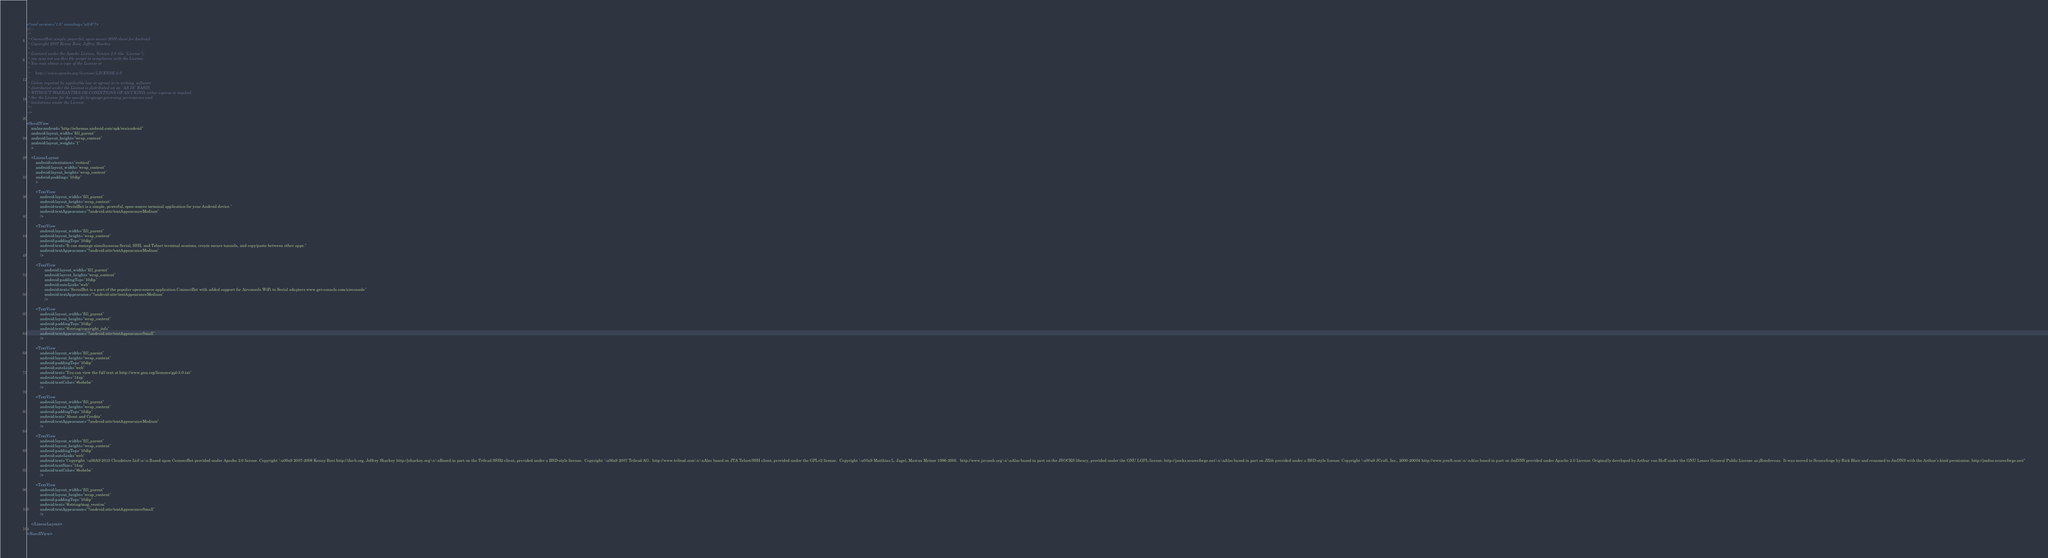<code> <loc_0><loc_0><loc_500><loc_500><_XML_><?xml version="1.0" encoding="utf-8"?>
<!--
/*
 * ConnectBot: simple, powerful, open-source SSH client for Android
 * Copyright 2007 Kenny Root, Jeffrey Sharkey
 *
 * Licensed under the Apache License, Version 2.0 (the "License");
 * you may not use this file except in compliance with the License.
 * You may obtain a copy of the License at
 *
 *     http://www.apache.org/licenses/LICENSE-2.0
 *
 * Unless required by applicable law or agreed to in writing, software
 * distributed under the License is distributed on an "AS IS" BASIS,
 * WITHOUT WARRANTIES OR CONDITIONS OF ANY KIND, either express or implied.
 * See the License for the specific language governing permissions and
 * limitations under the License.
 */
-->

<ScrollView
	xmlns:android="http://schemas.android.com/apk/res/android"
	android:layout_width="fill_parent"
	android:layout_height="wrap_content"
	android:layout_weight="1"
	>

	<LinearLayout
		android:orientation="vertical"
		android:layout_width="wrap_content"
		android:layout_height="wrap_content"
		android:padding="10dip"
		>

		<TextView
			android:layout_width="fill_parent"
			android:layout_height="wrap_content"
			android:text="SerialBot is a simple, powerful, open-source terminal application for your Android device."
			android:textAppearance="?android:attr/textAppearanceMedium"
			/>

		<TextView
			android:layout_width="fill_parent"
			android:layout_height="wrap_content"
			android:paddingTop="10dip"
			android:text="It can manage simultaneous Serial, SSH, and Telnet terminal sessions, create secure tunnels, and copy/paste between other apps."
			android:textAppearance="?android:attr/textAppearanceMedium"
			/>

        <TextView
                android:layout_width="fill_parent"
                android:layout_height="wrap_content"
                android:paddingTop="10dip"
                android:autoLink="web"
                android:text="SerialBot is a port of the popular open-source application ConnectBot with added support for Airconsole WiFi to Serial adapters www.get-console.com/airconsole"
                android:textAppearance="?android:attr/textAppearanceMedium"
                />

        <TextView
			android:layout_width="fill_parent"
			android:layout_height="wrap_content"
			android:paddingTop="10dip"
			android:text="@string/copyright_info"
			android:textAppearance="?android:attr/textAppearanceSmall"
			/>

		<TextView
			android:layout_width="fill_parent"
			android:layout_height="wrap_content"
			android:paddingTop="10dip"
			android:autoLink="web"
			android:text="You can view the full text at http://www.gnu.org/licenses/gpl-3.0.txt"
			android:textSize="14sp"
			android:textColor="#bebebe"
			/>

 		<TextView
			android:layout_width="fill_parent"
			android:layout_height="wrap_content"
			android:paddingTop="10dip"
			android:text="About and Credits"
			android:textAppearance="?android:attr/textAppearanceMedium"
			/>

		<TextView
			android:layout_width="fill_parent"
			android:layout_height="wrap_content"
			android:paddingTop="10dip"
			android:autoLink="web"
			android:text="Copyright \u00A9 2013 Cloudstore Ltd\n\n Based upon ConnectBot provided under Apache 2.0 licence. Copyright \u00a9 2007-2008 Kenny Root http://the-b.org, Jeffrey Sharkey http://jsharkey.org\n\nBased in part on the Trilead SSH2 client, provided under a BSD-style license.  Copyright \u00a9 2007 Trilead AG.  http://www.trilead.com\n\nAlso based on JTA Telnet/SSH client, provided under the GPLv2 license.  Copyright \u00a9 Matthias L. Jugel, Marcus Meiner 1996-2005.  http://www.javassh.org\n\nAlso based in part on the JSOCKS library, provided under the GNU LGPL license. http://jsocks.sourceforge.net\n\nAlso based in part on JZlib provided under a BSD-style license. Copyright \u00a9 JCraft, Inc., 2000-20004 http://www.jcraft.com\n\nAlso based in part on JmDNS provided under Apache 2.0 License. Originally developed by Arthur van Hoff under the GNU Lesser General Public License as jRendevous.  It was moved to Sourceforge by Rick Blair and renamed to JmDNS with the Arthur's kind permission. http://jmdns.sourceforge.net/"
			android:textSize="14sp"
			android:textColor="#bebebe"
			/>

		<TextView
			android:layout_width="fill_parent"
			android:layout_height="wrap_content"
			android:paddingTop="10dip"
			android:text="@string/msg_version"
			android:textAppearance="?android:attr/textAppearanceSmall"
			/>

	</LinearLayout>

</ScrollView>
</code> 